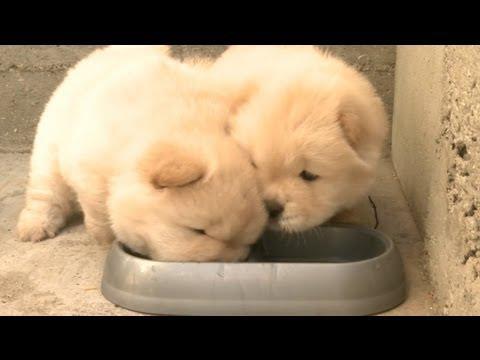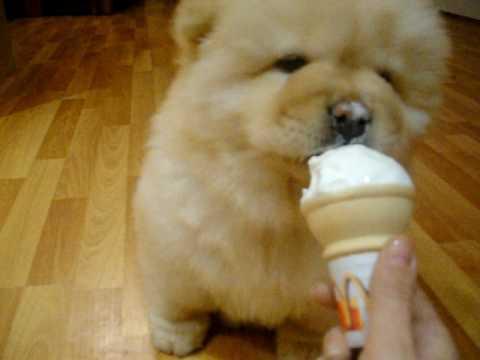The first image is the image on the left, the second image is the image on the right. Considering the images on both sides, is "A dog is eating food." valid? Answer yes or no. Yes. The first image is the image on the left, the second image is the image on the right. Analyze the images presented: Is the assertion "there are 3 dogs in the image pair" valid? Answer yes or no. Yes. 